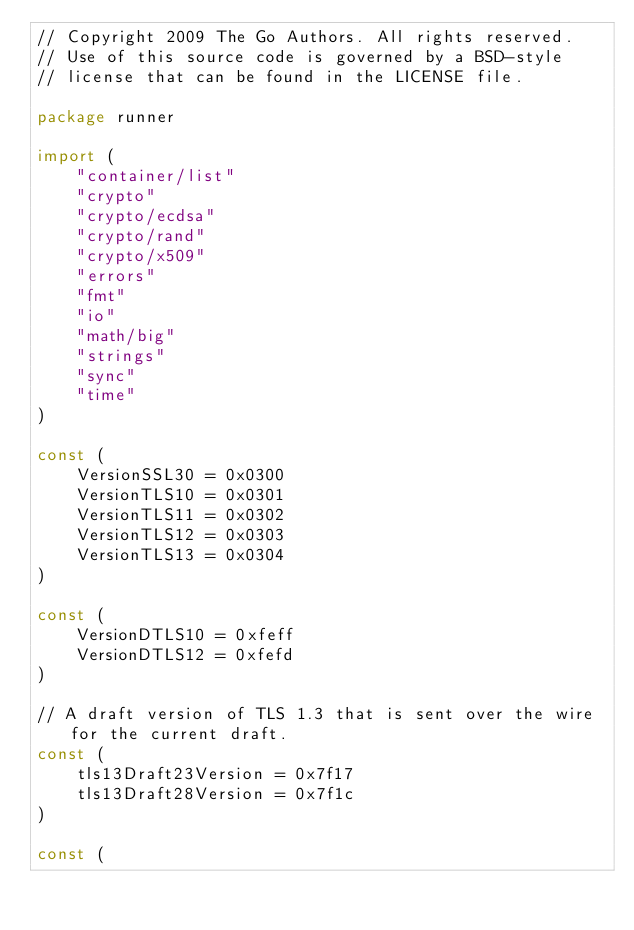Convert code to text. <code><loc_0><loc_0><loc_500><loc_500><_Go_>// Copyright 2009 The Go Authors. All rights reserved.
// Use of this source code is governed by a BSD-style
// license that can be found in the LICENSE file.

package runner

import (
	"container/list"
	"crypto"
	"crypto/ecdsa"
	"crypto/rand"
	"crypto/x509"
	"errors"
	"fmt"
	"io"
	"math/big"
	"strings"
	"sync"
	"time"
)

const (
	VersionSSL30 = 0x0300
	VersionTLS10 = 0x0301
	VersionTLS11 = 0x0302
	VersionTLS12 = 0x0303
	VersionTLS13 = 0x0304
)

const (
	VersionDTLS10 = 0xfeff
	VersionDTLS12 = 0xfefd
)

// A draft version of TLS 1.3 that is sent over the wire for the current draft.
const (
	tls13Draft23Version = 0x7f17
	tls13Draft28Version = 0x7f1c
)

const (</code> 